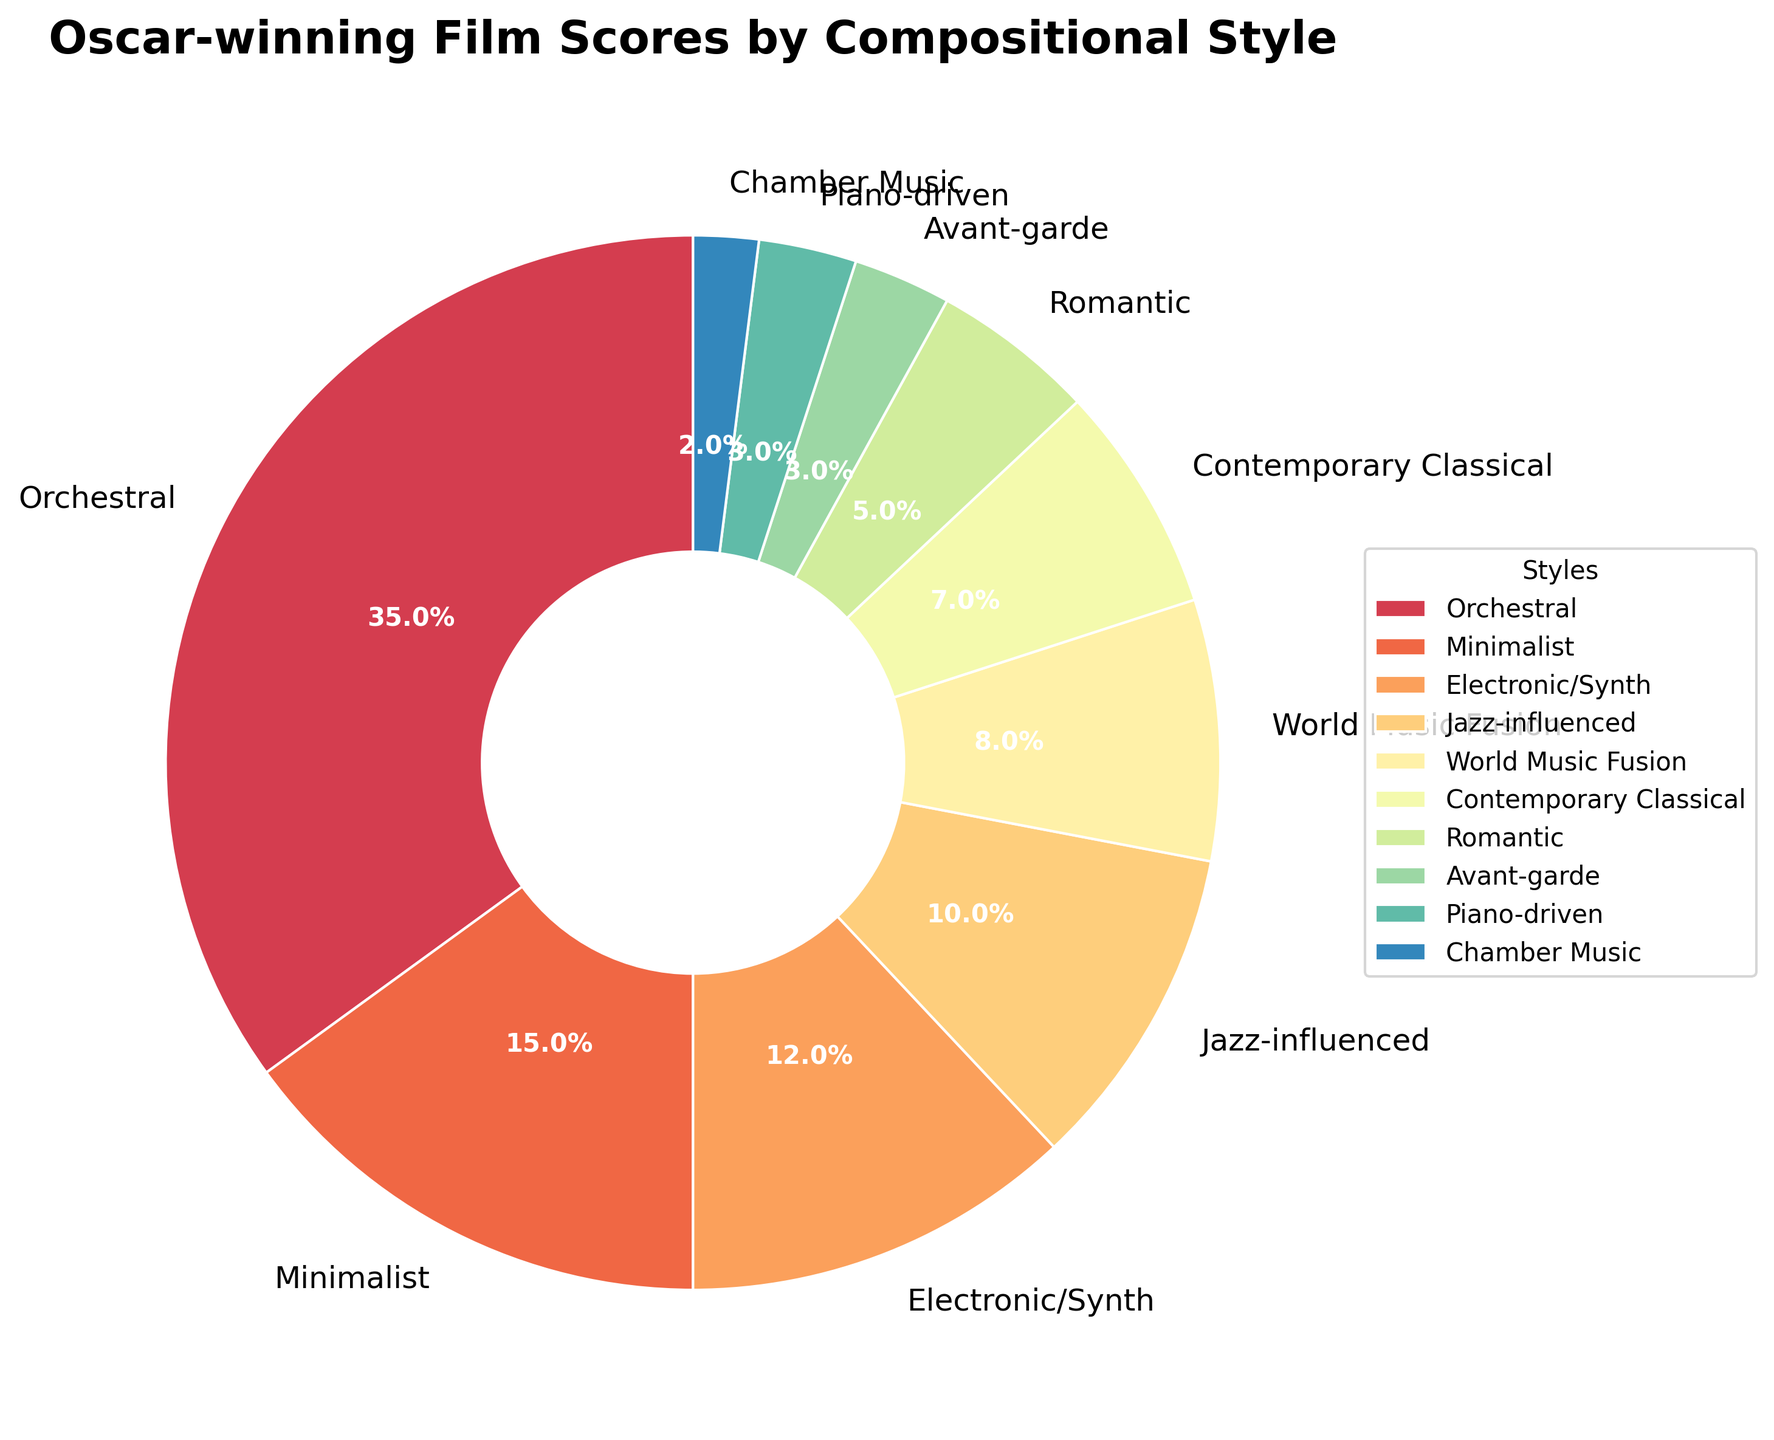Which compositional style has the largest percentage? The largest percentage is easy to identify by looking at the slice with the greatest size or the highest percentage label. The "Orchestral" style has the largest slice.
Answer: Orchestral What is the combined percentage of "Electronic/Synth" and "Jazz-influenced" styles? Add the percentages of "Electronic/Synth" (12%) and "Jazz-influenced" (10%) together. 12% + 10% = 22%
Answer: 22% Which styles have the least representation in Oscar-winning film scores? Identify the segments with the smallest size or the lowest percentages. "Avant-garde," "Piano-driven," and "Chamber Music" each have the smallest percentages at 3%, 3%, and 2%, respectively.
Answer: Avant-garde, Piano-driven, Chamber Music How much more popular is the "Orchestral" style compared to the "Contemporary Classical" style? Subtract the percentage of "Contemporary Classical" (7%) from "Orchestral" (35%). 35% - 7% = 28%
Answer: 28% Is the percentage of "Minimalist" style greater than the sum of "Romantic" and "Chamber Music" styles? Calculate the sum of "Romantic" (5%) and "Chamber Music" (2%): 5% + 2% = 7%. Compare it with "Minimalist" (15%). Since 15% > 7%, "Minimalist" is greater.
Answer: Yes Which style has a percentage twice that of "World Music Fusion"? If it exists. Double the "World Music Fusion" percentage (8% * 2 = 16%). There is no style with exactly 16%, so none fits this criterion.
Answer: None What is the median percentage value of the compositional styles? Order the percentages in ascending order: 2%, 3%, 3%, 5%, 7%, 8%, 10%, 12%, 15%, 35%. With 10 values, the median is the average of the 5th and 6th values: (7% + 8%)/2 = 7.5%
Answer: 7.5% What's the percentage difference between the "Minimalist" and "Electronic/Synth" styles? Subtract the percentage of "Electronic/Synth" (12%) from "Minimalist" (15%): 15% - 12% = 3%
Answer: 3% Among "Contemporary Classical," "Romantic," and "Jazz-influenced" styles, which has the highest percentage? Compare the percentages: "Contemporary Classical" (7%), "Romantic" (5%), "Jazz-influenced" (10%). The highest is "Jazz-influenced."
Answer: Jazz-influenced 